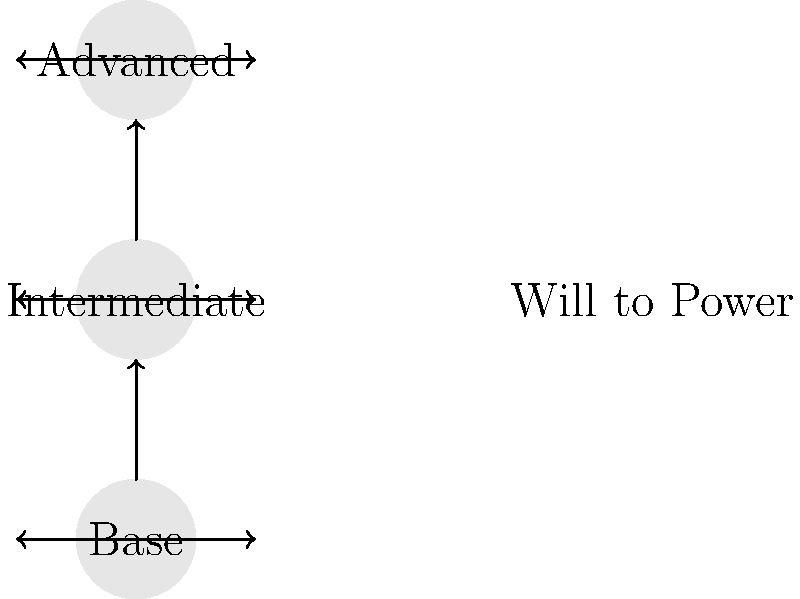In Nietzsche's philosophy, the concept of "will to power" is central. How does this diagram illustrate the idea of "will to power" using hierarchical structures and dynamic arrow designs? Explain the significance of the vertical progression and horizontal arrows in relation to this concept. 1. Hierarchical Structure:
   - The diagram shows three levels: Base, Intermediate, and Advanced.
   - This represents the hierarchical nature of power in Nietzsche's philosophy.

2. Vertical Progression:
   - Upward arrows between levels symbolize the drive to ascend in power.
   - This illustrates Nietzsche's idea that life constantly strives to overcome itself.

3. Horizontal Arrows:
   - Arrows at each level represent expansion or growth within that stage.
   - This shows that the will to power operates at all levels, not just in vertical progression.

4. Dynamic Design:
   - The combination of vertical and horizontal arrows creates a dynamic visual.
   - This represents the constant flux and struggle inherent in the will to power.

5. "Will to Power" Label:
   - The label on the right ties the entire structure to Nietzsche's concept.
   - It emphasizes that this drive permeates all levels and directions of growth.

6. Artistic Interpretation:
   - The clean, geometric design reflects an artistic approach to philosophical concepts.
   - The use of arrows and levels provides a visual metaphor for abstract ideas.

7. Continuous Nature:
   - The open-ended top level suggests that the process is ongoing.
   - This aligns with Nietzsche's view that the will to power is a perpetual force.

The diagram effectively illustrates the will to power as a multidirectional, hierarchical, and continuous force driving growth and expansion at all levels of existence.
Answer: Hierarchical progression and multidirectional expansion representing continuous growth and self-overcoming. 